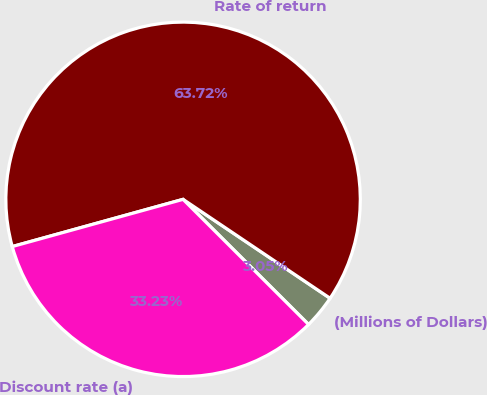Convert chart. <chart><loc_0><loc_0><loc_500><loc_500><pie_chart><fcel>(Millions of Dollars)<fcel>Rate of return<fcel>Discount rate (a)<nl><fcel>3.05%<fcel>63.72%<fcel>33.23%<nl></chart> 